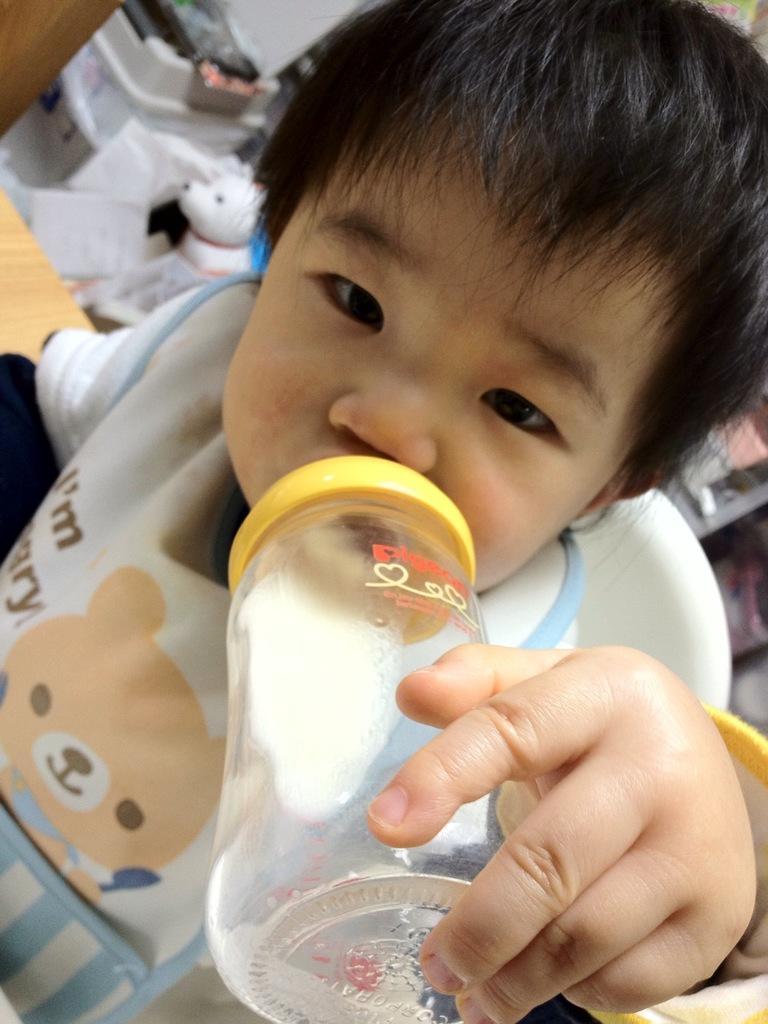How would you summarize this image in a sentence or two? In this image I see a child who is sitting on a chair and there is a bottle over here. 